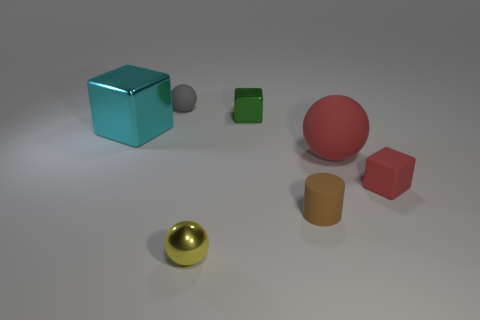Is there a sense of balance or symmetry in this composition? The composition does have a sense of informal balance. While it's not symmetrical, the placement of the objects has a thoughtful asymmetry that creates a pleasing visual effect. The varying sizes and colors of the objects are distributed in a way that seems stable and aesthetically balanced, despite not being mirrored on any axis. 